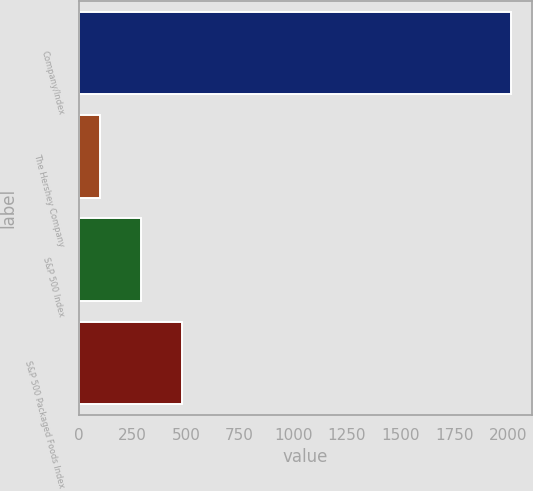Convert chart. <chart><loc_0><loc_0><loc_500><loc_500><bar_chart><fcel>Company/Index<fcel>The Hershey Company<fcel>S&P 500 Index<fcel>S&P 500 Packaged Foods Index<nl><fcel>2012<fcel>100<fcel>291.2<fcel>482.4<nl></chart> 